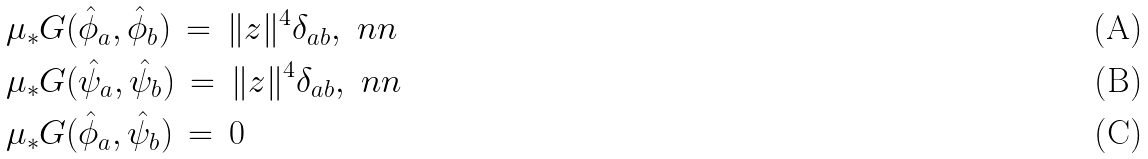<formula> <loc_0><loc_0><loc_500><loc_500>& \mu _ { * } G ( \hat { \phi } _ { a } , \hat { \phi } _ { b } ) \, = \, \| z \| ^ { 4 } \delta _ { a b } , \ n n \\ & \mu _ { * } G ( \hat { \psi } _ { a } , \hat { \psi } _ { b } ) \, = \, \| z \| ^ { 4 } \delta _ { a b } , \ n n \\ & \mu _ { * } G ( \hat { \phi } _ { a } , \hat { \psi } _ { b } ) \, = \, 0</formula> 